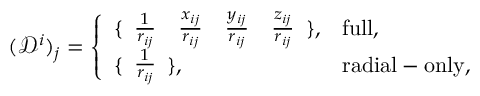Convert formula to latex. <formula><loc_0><loc_0><loc_500><loc_500>( \mathcal { D } ^ { i } ) _ { j } = \left \{ \begin{array} { l l } { \{ \begin{array} { c c c c } { \frac { 1 } { r _ { i j } } } & { \frac { x _ { i j } } { r _ { i j } } } & { \frac { y _ { i j } } { r _ { i j } } } & { \frac { z _ { i j } } { r _ { i j } } } \end{array} \} , } & { f u l l , } \\ { \{ \begin{array} { c } { \frac { 1 } { r _ { i j } } } \end{array} \} , } & { r a d i a l - o n l y , } \end{array}</formula> 